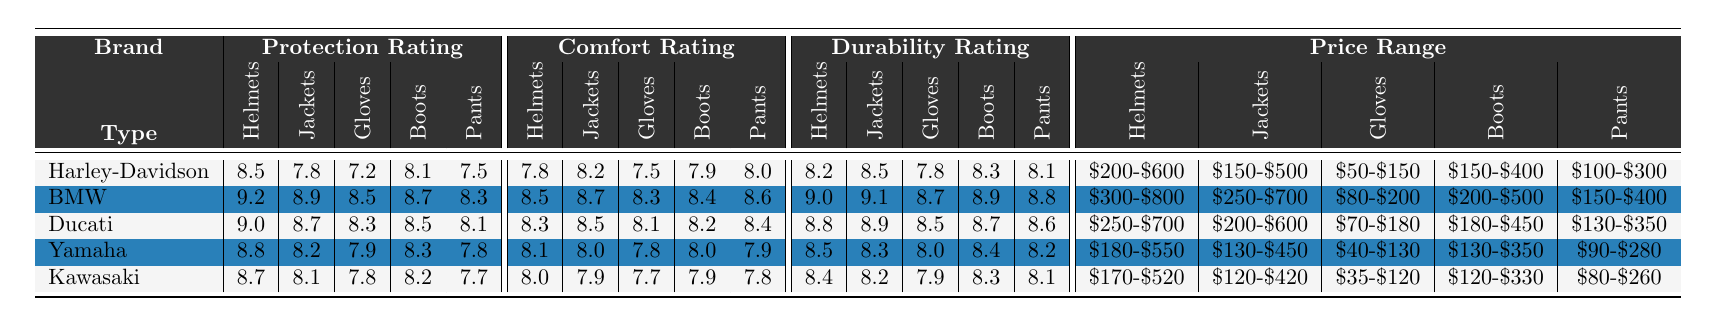What brand has the highest helmet protection rating? Looking at the helmet protection ratings, BMW has the highest rating of 9.2 compared to other brands.
Answer: BMW What is the comfort rating of Ducati jackets? The table shows that Ducati jackets have a comfort rating of 8.5.
Answer: 8.5 Which brand offers gloves at the lowest price range? In the price range column, Kawasaki offers gloves for $35-$120, which is the lowest among all brands.
Answer: Kawasaki What is the average protection rating for Yamaha gear? The protection ratings for Yamaha's gear are 8.8 (Helmets), 8.2 (Jackets), 7.9 (Gloves), 8.3 (Boots), and 7.8 (Pants). Summing them up gives 8.8 + 8.2 + 7.9 + 8.3 + 7.8 = 41.0, and dividing by 5 gives an average of 41.0 / 5 = 8.2.
Answer: 8.2 Do Harley-Davidson pants have a higher comfort rating than their gloves? Harley-Davidson pants have a comfort rating of 8.0, while their gloves have a rating of 7.5, indicating that pants have a higher rating than gloves.
Answer: Yes Which brand has the lowest durability rating for boots? Checking the durability ratings, Kawasaki boots have the lowest rating of 8.3 compared to the other brands' ratings for boots.
Answer: Kawasaki What is the difference between the protection ratings of BMW helmets and Harley-Davidson helmets? BMW helmets have a protection rating of 9.2 and Harley-Davidson helmets have a rating of 8.5. The difference is 9.2 - 8.5 = 0.7.
Answer: 0.7 Which brand has the best overall combination of comfort and durability for jackets? For jackets, BMW has a comfort rating of 8.7 and a durability rating of 9.1. Summing these gives 8.7 + 9.1 = 17.8, which is higher than any other brand's sum for jackets.
Answer: BMW Is Ducati's comfort rating for gloves greater than that of Yamaha? Ducati gloves have a comfort rating of 8.1 while Yamaha gloves have a comfort rating of 7.8. Thus, Ducati’s rating is greater than Yamaha’s.
Answer: Yes What brand offers the widest price range for boots? BMW offers a price range for boots of $200-$500, which is wider than the other brands.
Answer: BMW 